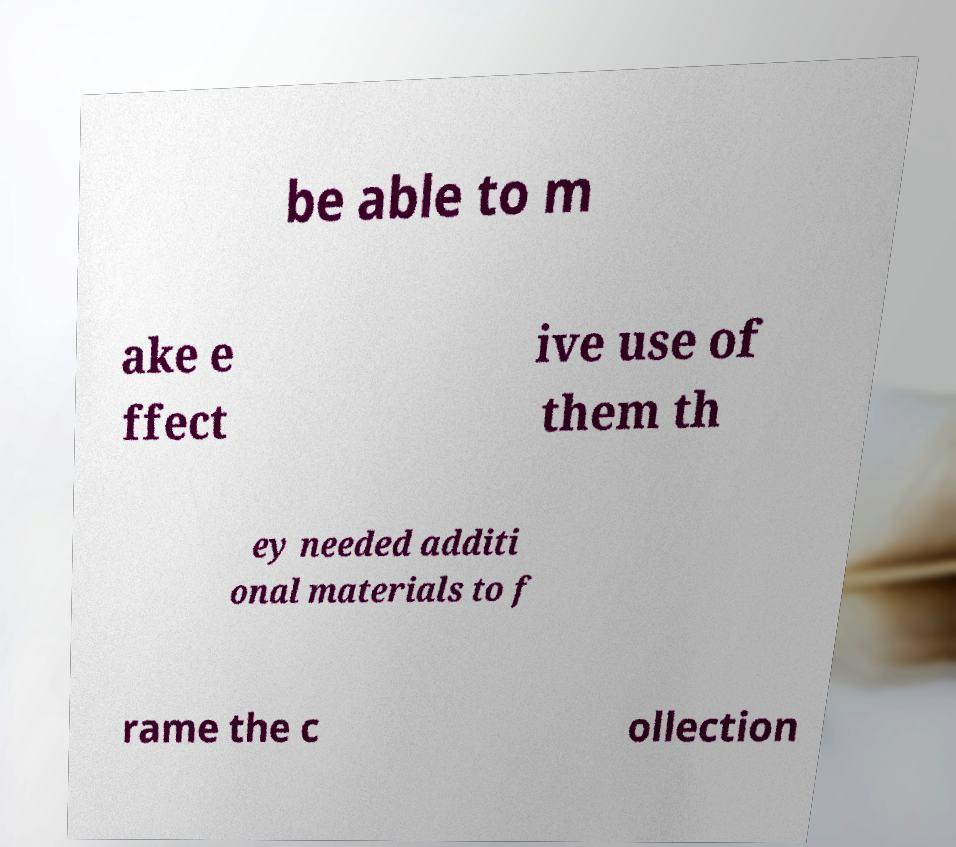Please identify and transcribe the text found in this image. be able to m ake e ffect ive use of them th ey needed additi onal materials to f rame the c ollection 